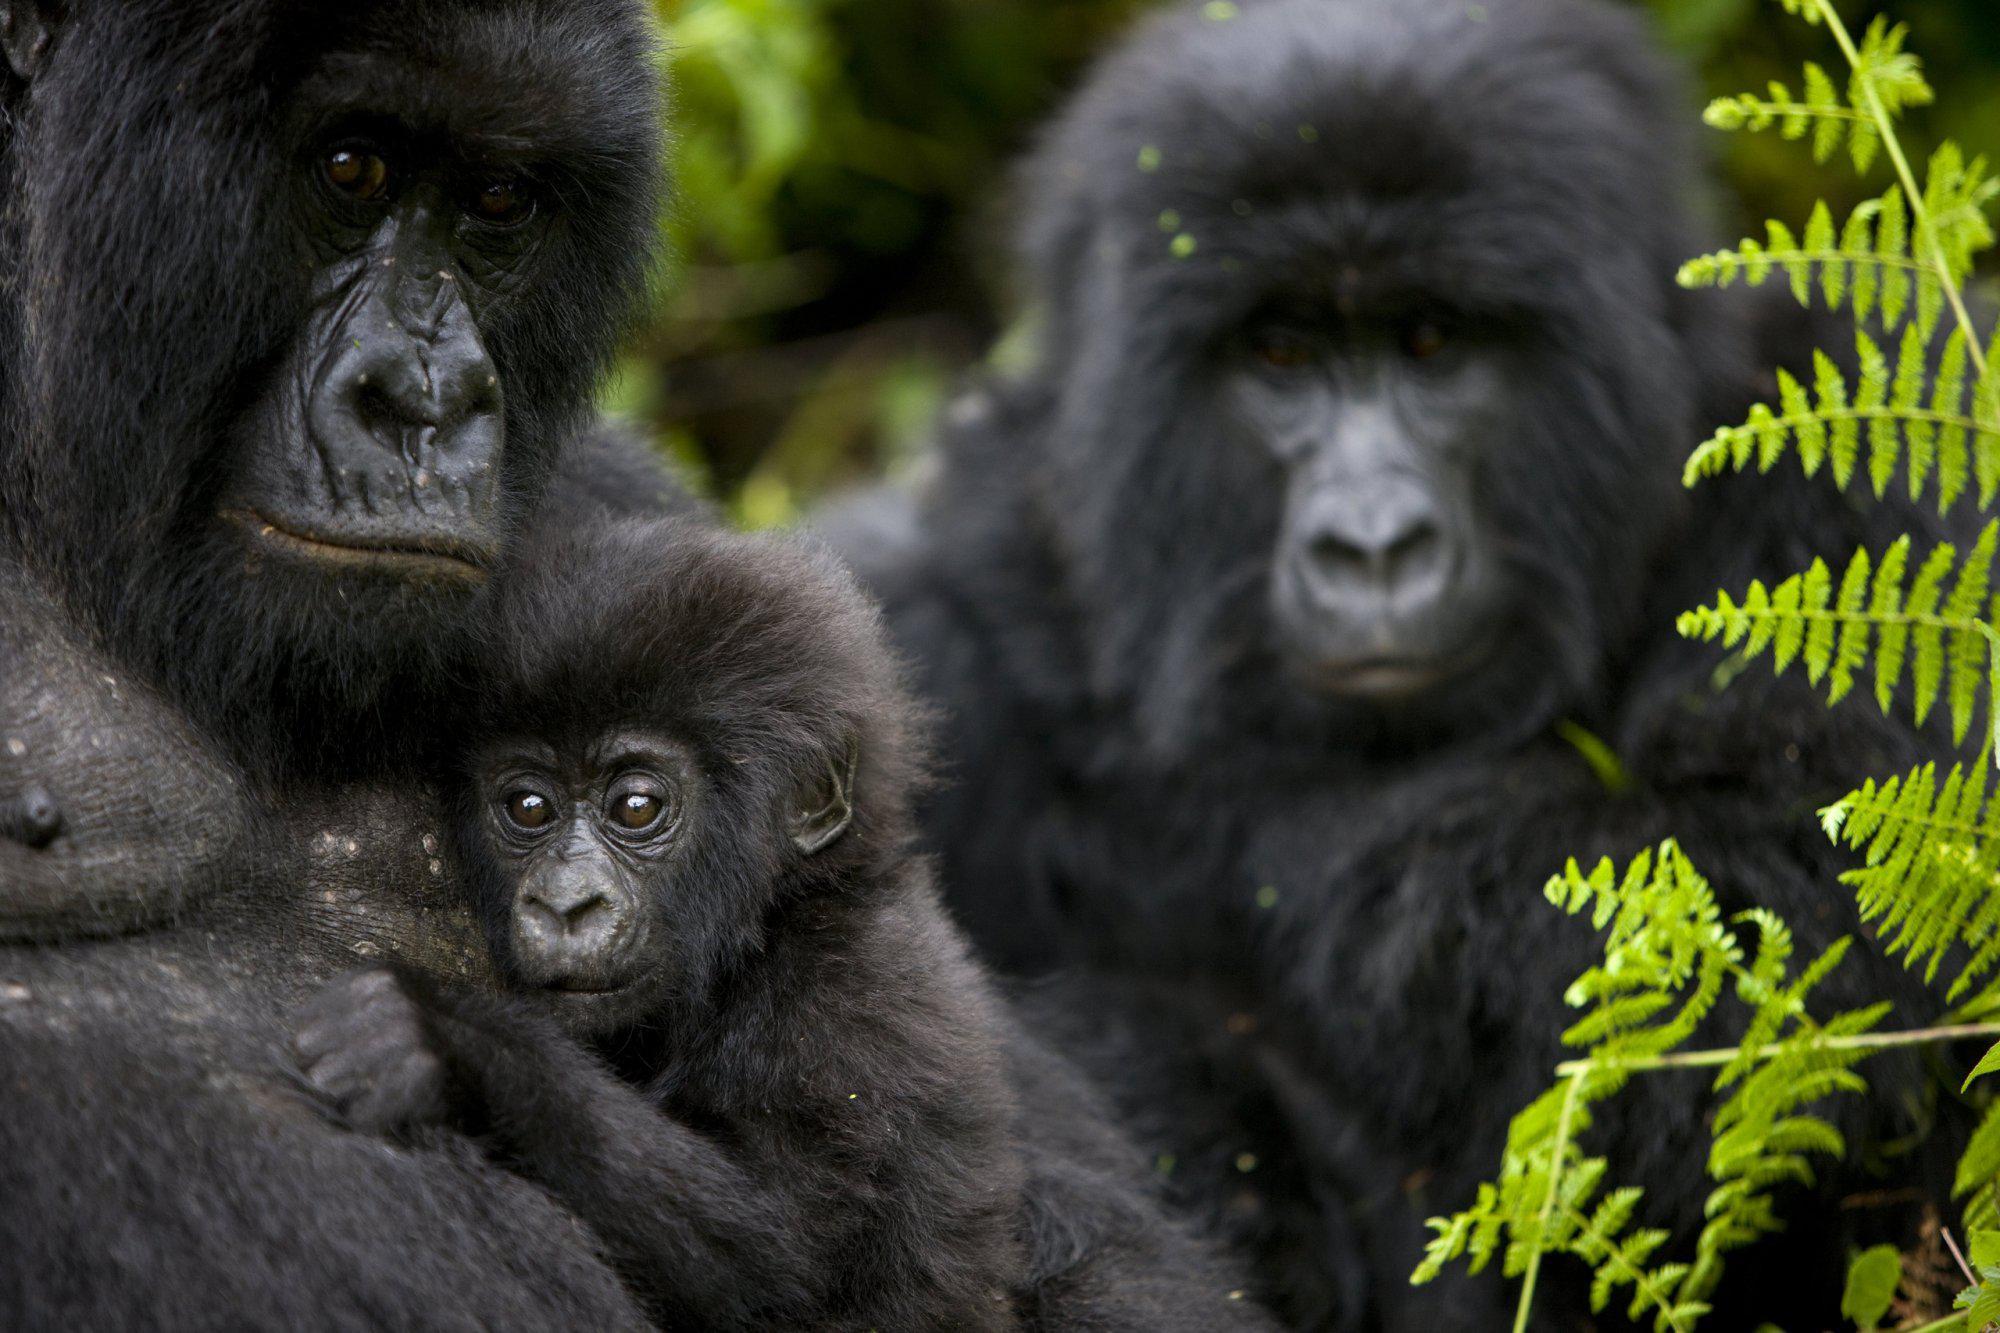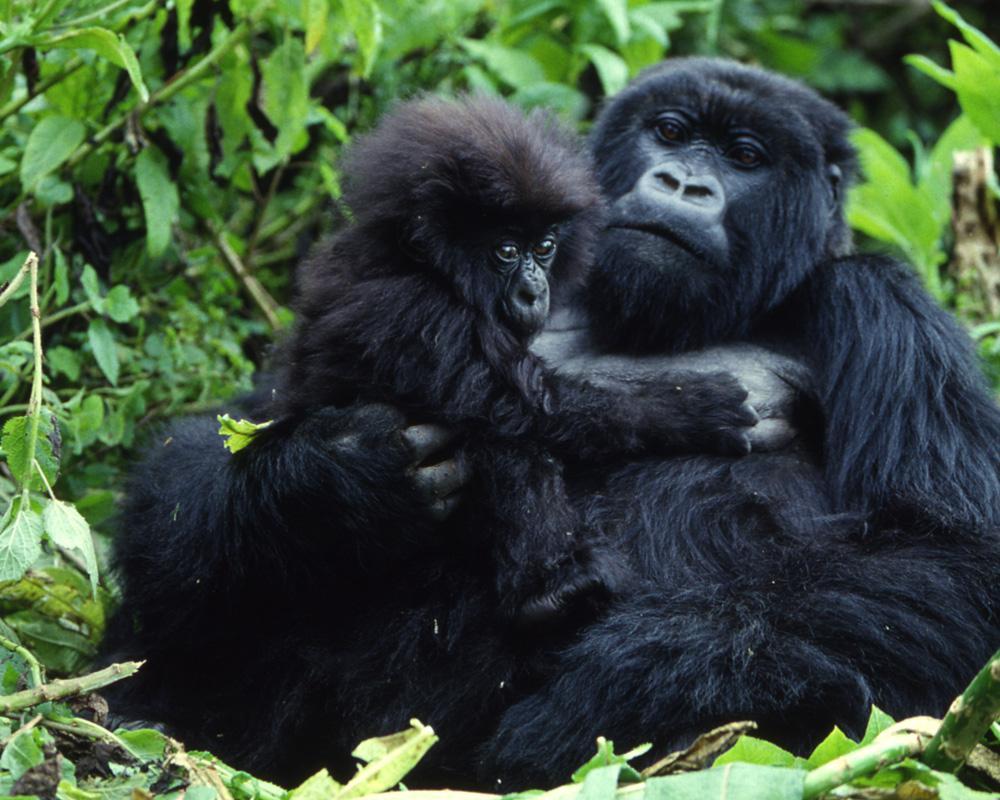The first image is the image on the left, the second image is the image on the right. For the images shown, is this caption "The right image includes no more than two apes." true? Answer yes or no. Yes. The first image is the image on the left, the second image is the image on the right. For the images displayed, is the sentence "Three gorillas sit in the grass in the image on the right." factually correct? Answer yes or no. No. 